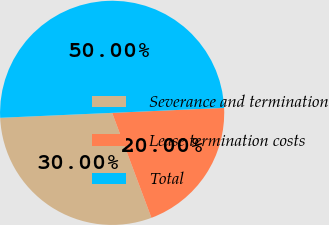<chart> <loc_0><loc_0><loc_500><loc_500><pie_chart><fcel>Severance and termination<fcel>Lease termination costs<fcel>Total<nl><fcel>30.0%<fcel>20.0%<fcel>50.0%<nl></chart> 